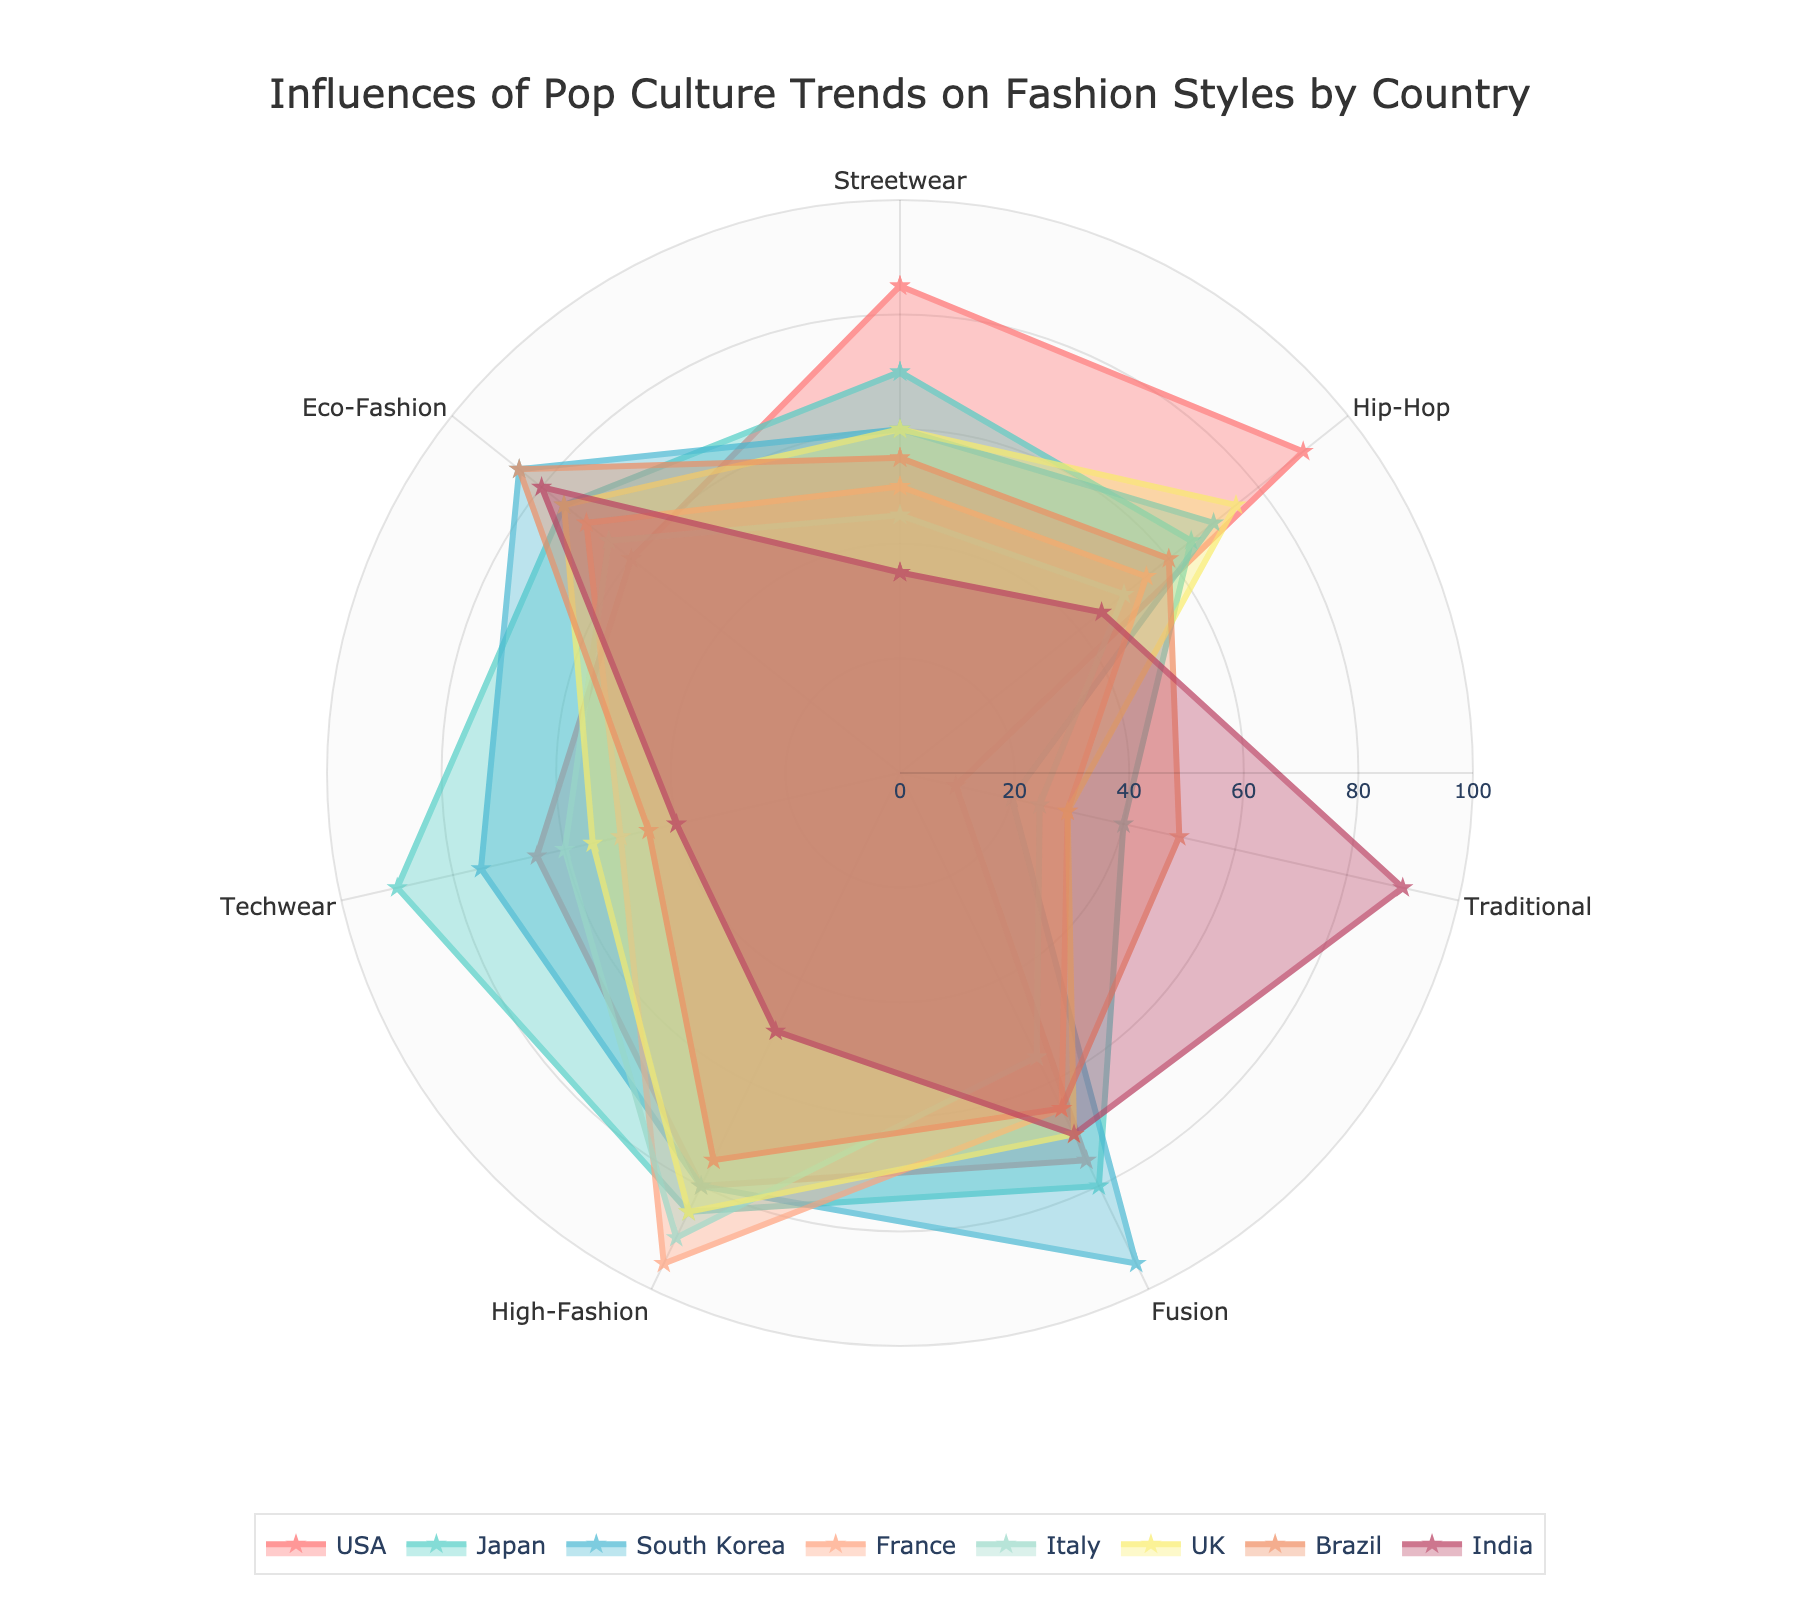What's the title of the figure? The title is usually positioned prominently at the top of the chart. In this case, it is written as part of the plot layout.
Answer: Influences of Pop Culture Trends on Fashion Styles by Country Which country appears to have the highest influence of Traditional fashion style? To determine this, look at the values for Traditional fashion style around the radar chart. The highest value corresponds to India.
Answer: India How does the influence of Eco-Fashion in Brazil compare to that in South Korea? Look at the radial values for Eco-Fashion for both Brazil and South Korea. Brazil has a value of 85 while South Korea has a value of 85. Both are equal.
Answer: Equal What is the average influence of High-Fashion across all countries? Add up the High-Fashion values for each country and divide by the number of countries: (80 + 85 + 80 + 95 + 90 + 85 + 75 + 50) / 8 = 640 / 8.
Answer: 80 Which country has the least influence of Streetwear? By comparing the values for Streetwear in each country, India has the lowest value, which is 35.
Answer: India How does the influence of Techwear in Japan and Italy compare? Check the Techwear values for both Japan and Italy. Japan has a value of 90 while Italy has a value of 60. Japan's influence is higher.
Answer: Japan's influence is higher What is the total influence of Hip-Hop and Fusion styles in the USA? Sum the values of Hip-Hop and Fusion for the USA: 90 + 75 = 165.
Answer: 165 Which country has the most balanced influence across all fashion styles, based on visual appearance? A balanced influence would have values closer to each other, forming a more circular shape. The radar chart for Brazil appears the most balanced with no extreme highs or lows.
Answer: Brazil What are the three countries with the highest influence of Fusion fashion style? Look at the Fusion values and find the top three: South Korea (95), Japan (80), and USA (75).
Answer: South Korea, Japan, USA For the UK, what is the difference between the influences of Streetwear and Techwear styles? Subtract the Techwear value from the Streetwear value for the UK: 60 - 55 = 5.
Answer: 5 